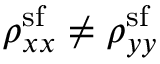<formula> <loc_0><loc_0><loc_500><loc_500>\rho _ { x x } ^ { s f } \neq \rho _ { y y } ^ { s f }</formula> 